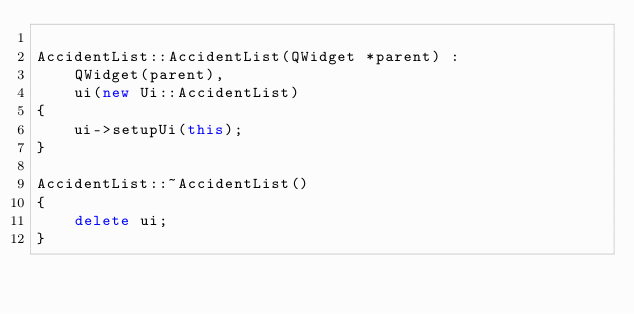<code> <loc_0><loc_0><loc_500><loc_500><_C++_>
AccidentList::AccidentList(QWidget *parent) :
    QWidget(parent),
    ui(new Ui::AccidentList)
{
    ui->setupUi(this);
}

AccidentList::~AccidentList()
{
    delete ui;
}
</code> 